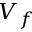Convert formula to latex. <formula><loc_0><loc_0><loc_500><loc_500>V _ { f }</formula> 